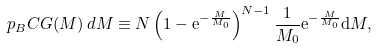Convert formula to latex. <formula><loc_0><loc_0><loc_500><loc_500>p _ { B } C G ( M ) \, d M \equiv N \left ( 1 - { \mathrm e } ^ { - \frac { M } { M _ { 0 } } } \right ) ^ { N - 1 } \frac { 1 } { M _ { 0 } } { \mathrm e } ^ { - \frac { M } { M _ { 0 } } } \mathrm d M ,</formula> 